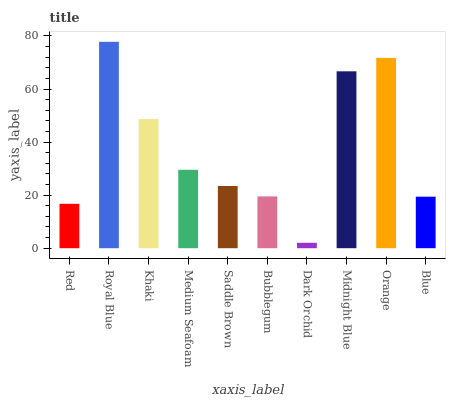Is Dark Orchid the minimum?
Answer yes or no. Yes. Is Royal Blue the maximum?
Answer yes or no. Yes. Is Khaki the minimum?
Answer yes or no. No. Is Khaki the maximum?
Answer yes or no. No. Is Royal Blue greater than Khaki?
Answer yes or no. Yes. Is Khaki less than Royal Blue?
Answer yes or no. Yes. Is Khaki greater than Royal Blue?
Answer yes or no. No. Is Royal Blue less than Khaki?
Answer yes or no. No. Is Medium Seafoam the high median?
Answer yes or no. Yes. Is Saddle Brown the low median?
Answer yes or no. Yes. Is Bubblegum the high median?
Answer yes or no. No. Is Royal Blue the low median?
Answer yes or no. No. 